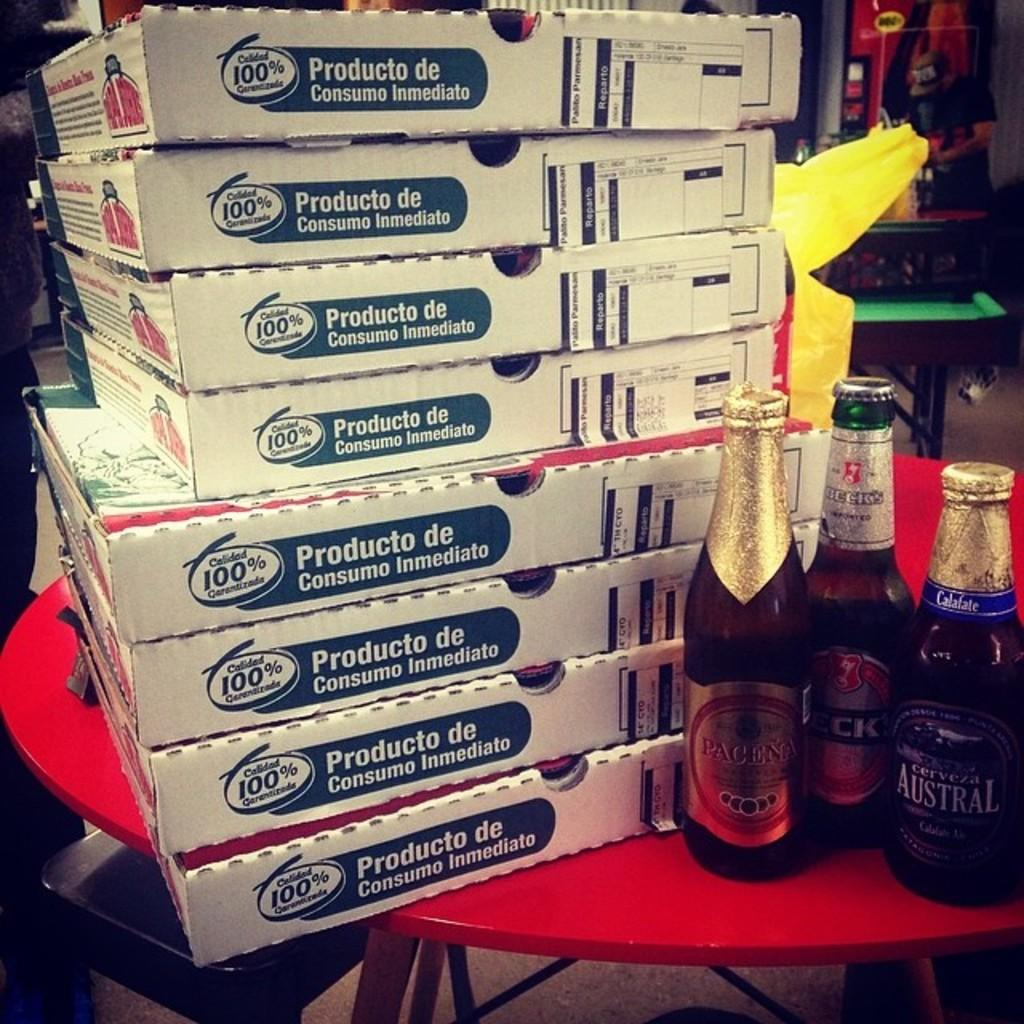<image>
Provide a brief description of the given image. A stack of Papa John's pizza boxes are piled high on a red table. 